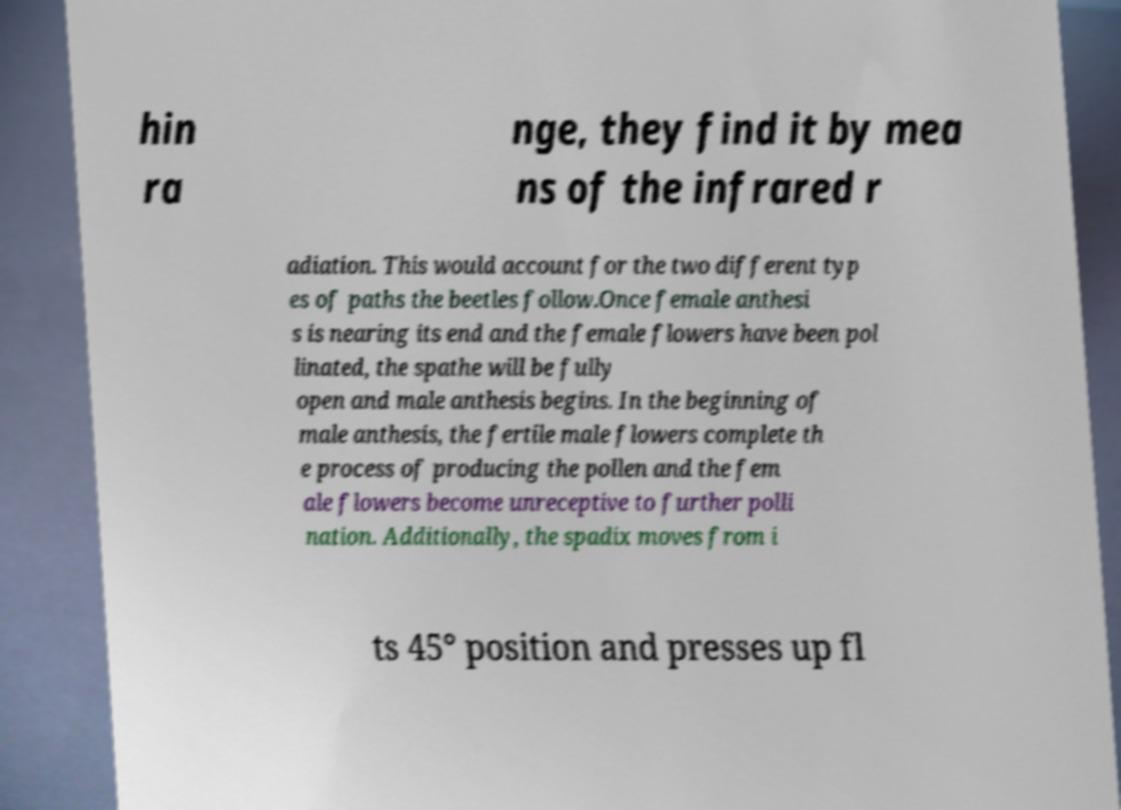Could you assist in decoding the text presented in this image and type it out clearly? hin ra nge, they find it by mea ns of the infrared r adiation. This would account for the two different typ es of paths the beetles follow.Once female anthesi s is nearing its end and the female flowers have been pol linated, the spathe will be fully open and male anthesis begins. In the beginning of male anthesis, the fertile male flowers complete th e process of producing the pollen and the fem ale flowers become unreceptive to further polli nation. Additionally, the spadix moves from i ts 45° position and presses up fl 